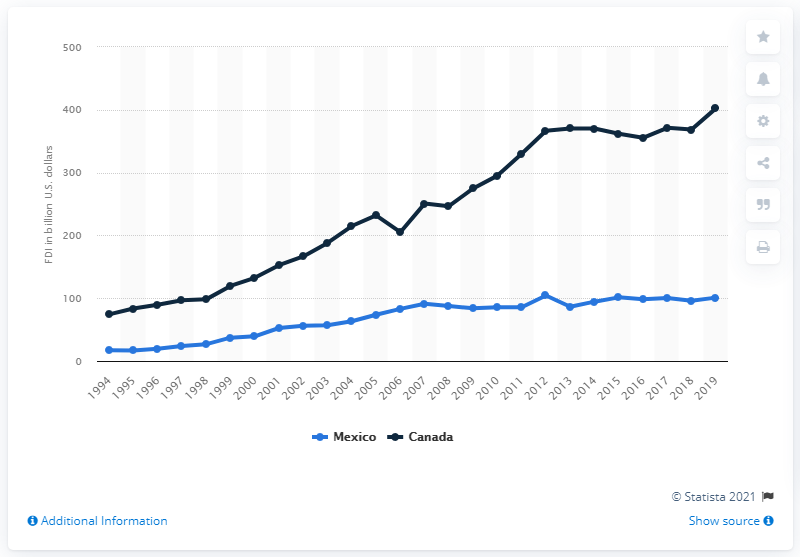Identify some key points in this picture. In 2019, the United States invested a substantial amount of money in Canada, totaling 402.26. 